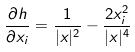Convert formula to latex. <formula><loc_0><loc_0><loc_500><loc_500>\frac { \partial h } { \partial x _ { i } } = \frac { 1 } { | x | ^ { 2 } } - \frac { 2 x _ { i } ^ { 2 } } { | x | ^ { 4 } }</formula> 